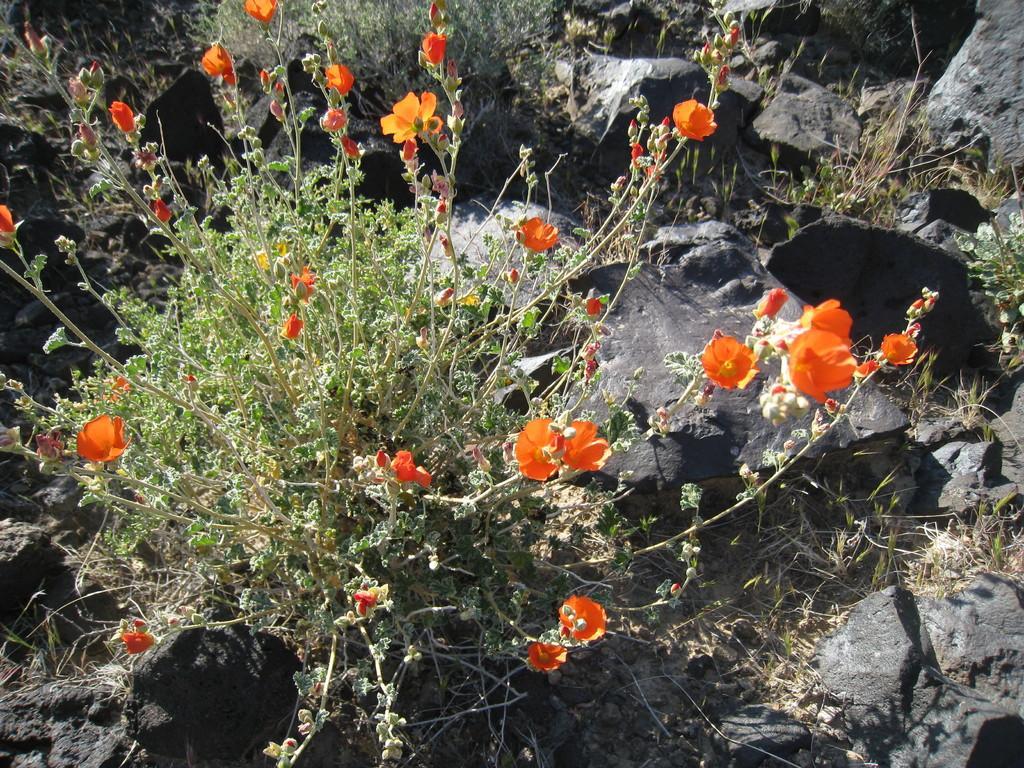In one or two sentences, can you explain what this image depicts? In the middle of the image, there is a plant having orange color flowers and green color leaves. This plant is on the ground, on which there are rocks and there are plants. 